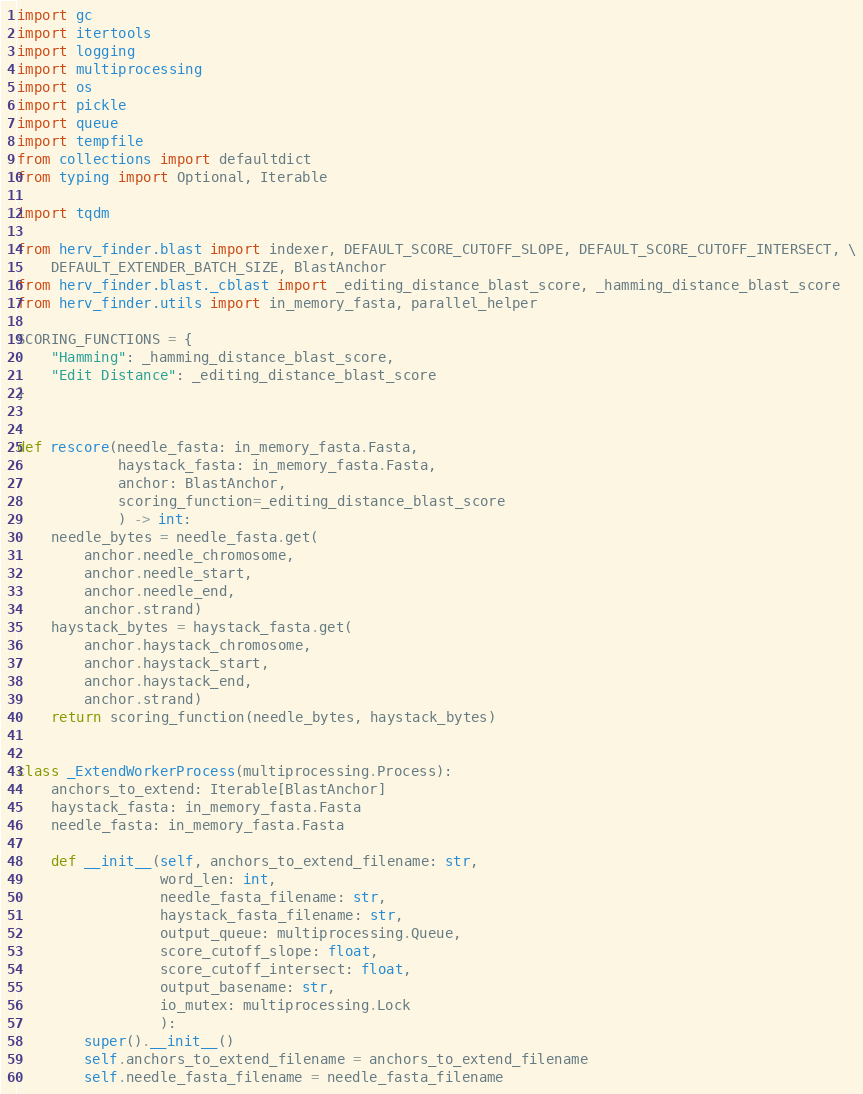Convert code to text. <code><loc_0><loc_0><loc_500><loc_500><_Python_>import gc
import itertools
import logging
import multiprocessing
import os
import pickle
import queue
import tempfile
from collections import defaultdict
from typing import Optional, Iterable

import tqdm

from herv_finder.blast import indexer, DEFAULT_SCORE_CUTOFF_SLOPE, DEFAULT_SCORE_CUTOFF_INTERSECT, \
    DEFAULT_EXTENDER_BATCH_SIZE, BlastAnchor
from herv_finder.blast._cblast import _editing_distance_blast_score, _hamming_distance_blast_score
from herv_finder.utils import in_memory_fasta, parallel_helper

SCORING_FUNCTIONS = {
    "Hamming": _hamming_distance_blast_score,
    "Edit Distance": _editing_distance_blast_score
}


def rescore(needle_fasta: in_memory_fasta.Fasta,
            haystack_fasta: in_memory_fasta.Fasta,
            anchor: BlastAnchor,
            scoring_function=_editing_distance_blast_score
            ) -> int:
    needle_bytes = needle_fasta.get(
        anchor.needle_chromosome,
        anchor.needle_start,
        anchor.needle_end,
        anchor.strand)
    haystack_bytes = haystack_fasta.get(
        anchor.haystack_chromosome,
        anchor.haystack_start,
        anchor.haystack_end,
        anchor.strand)
    return scoring_function(needle_bytes, haystack_bytes)


class _ExtendWorkerProcess(multiprocessing.Process):
    anchors_to_extend: Iterable[BlastAnchor]
    haystack_fasta: in_memory_fasta.Fasta
    needle_fasta: in_memory_fasta.Fasta

    def __init__(self, anchors_to_extend_filename: str,
                 word_len: int,
                 needle_fasta_filename: str,
                 haystack_fasta_filename: str,
                 output_queue: multiprocessing.Queue,
                 score_cutoff_slope: float,
                 score_cutoff_intersect: float,
                 output_basename: str,
                 io_mutex: multiprocessing.Lock
                 ):
        super().__init__()
        self.anchors_to_extend_filename = anchors_to_extend_filename
        self.needle_fasta_filename = needle_fasta_filename</code> 